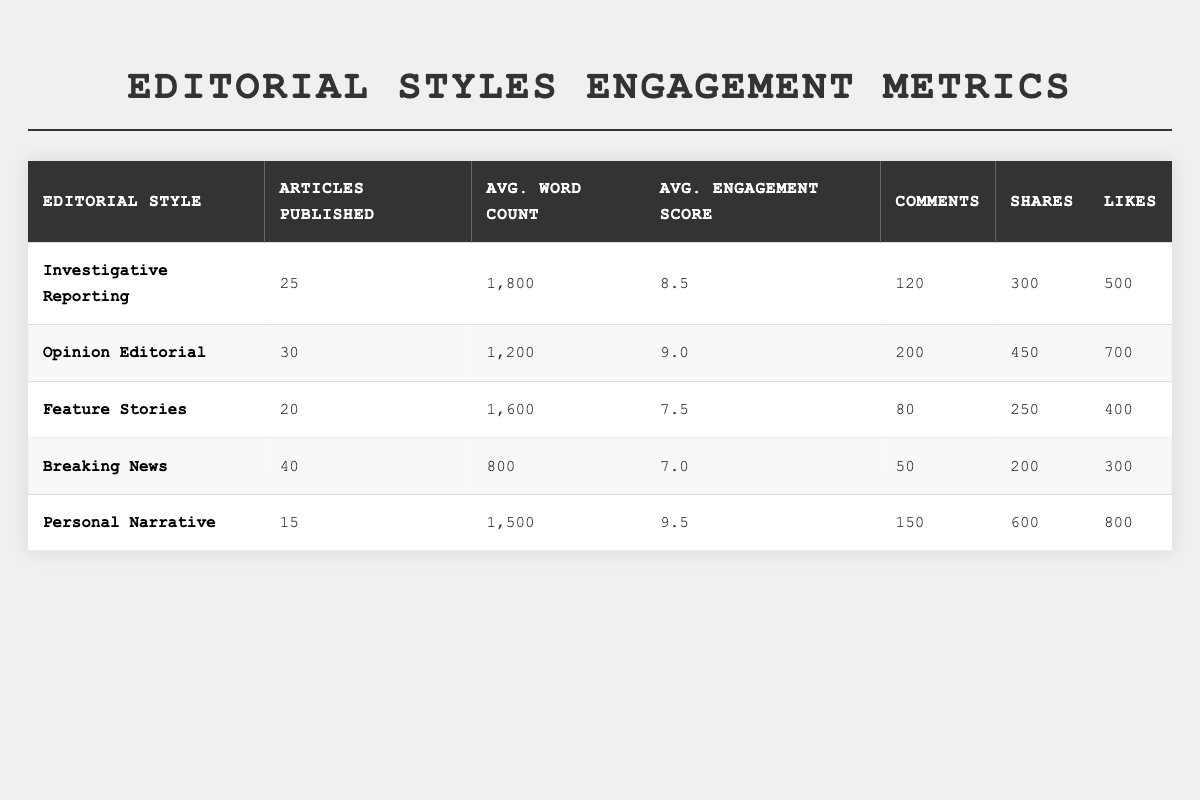What is the average engagement score for "Opinion Editorial" articles? The average engagement score for "Opinion Editorial" articles is directly given in the table as 9.0.
Answer: 9.0 How many articles were published in the "Breaking News" category? The number of articles published in "Breaking News" is stated in the table as 40.
Answer: 40 Which editorial style has the highest average word count? The average word count for "Investigative Reporting" is 1800, which is the highest compared to the other styles listed.
Answer: Investigative Reporting What is the total number of likes received across all editorial styles? The total likes can be calculated by adding likes from each style: 500 (Investigative) + 700 (Opinion) + 400 (Feature) + 300 (Breaking) + 800 (Personal) = 2700.
Answer: 2700 Is the average engagement score for "Personal Narrative" greater than 8? The average engagement score for "Personal Narrative" is 9.5, which is indeed greater than 8.
Answer: Yes How many more comments did "Opinion Editorials" receive compared to "Feature Stories"? The difference in comments is calculated as: 200 (Opinion) - 80 (Feature) = 120.
Answer: 120 Which editorial style had the least amount of articles published? "Personal Narrative" has the least number of articles published at 15.
Answer: Personal Narrative What is the average number of shares for articles published under the "Feature Stories" style? The average number of shares for "Feature Stories" is given directly as 250.
Answer: 250 If you were to rank the editorial styles by average engagement score, where would "Investigative Reporting" place? The average engagement scores from highest to lowest are: Personal Narrative (9.5), Opinion Editorial (9.0), Investigative Reporting (8.5), Feature Stories (7.5), and Breaking News (7.0), placing "Investigative Reporting" third.
Answer: Third Is it true that "Breaking News" has more articles published than "Feature Stories"? "Breaking News" has 40 articles while "Feature Stories" has 20, thus the statement is true.
Answer: Yes 